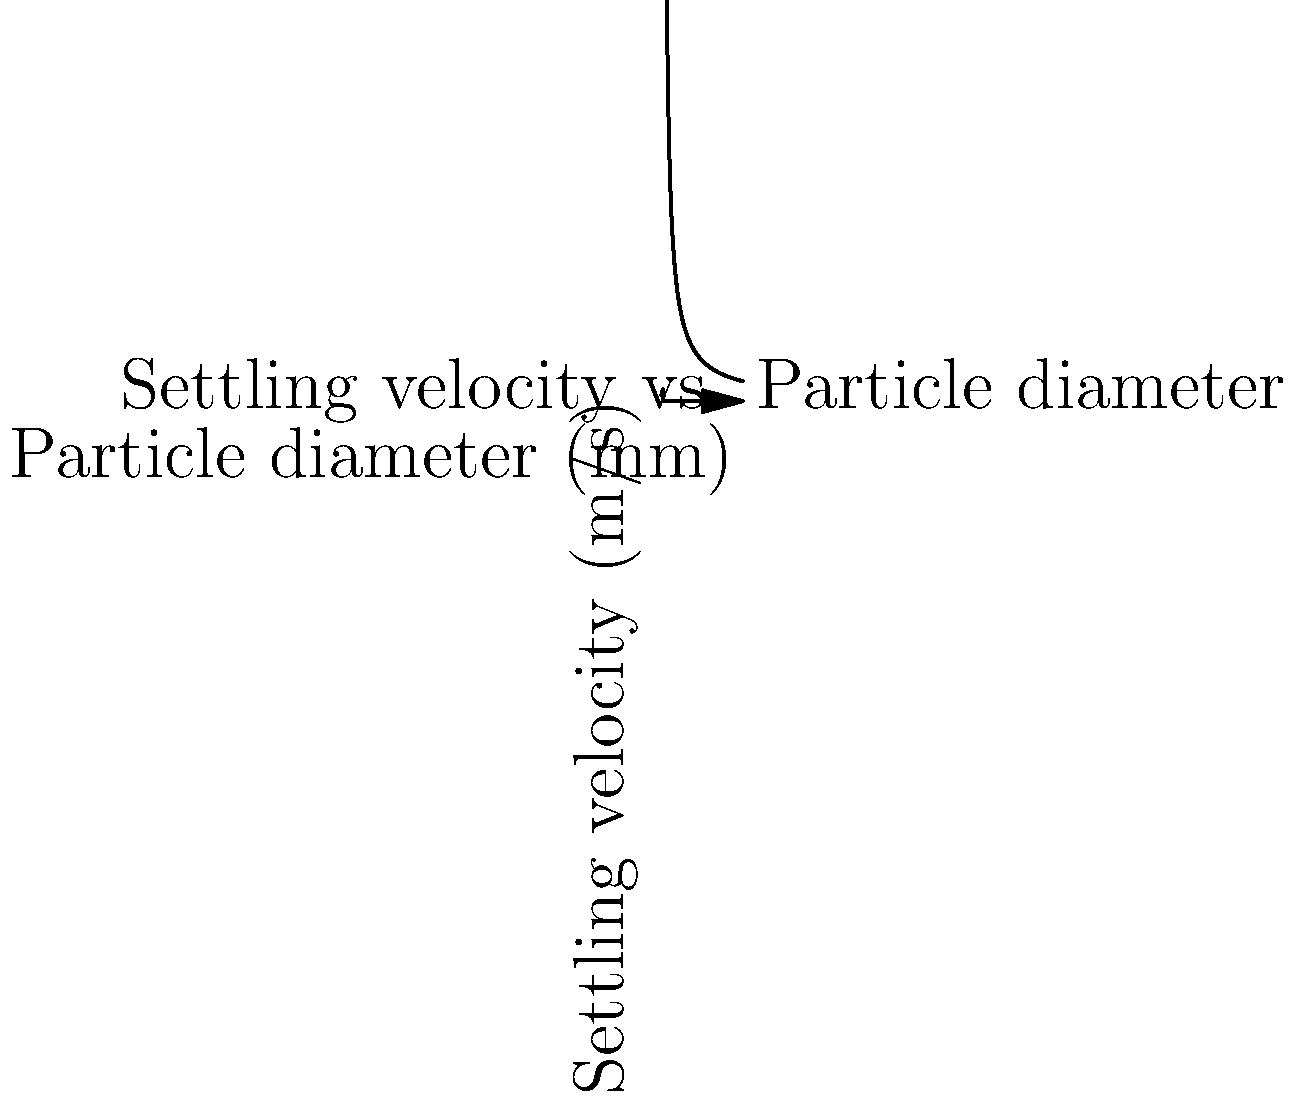A water treatment plant uses a sedimentation tank to remove suspended particles. Given the following information:
- Particle diameter: $0.5$ mm
- Particle density: $2650$ kg/m³
- Water density: $1000$ kg/m³
- Water dynamic viscosity: $0.001$ Pa·s
- Gravitational acceleration: $9.81$ m/s²
- Tank depth: $3$ m

Calculate the settling time (in seconds) for the particles to reach the bottom of the tank. Assume the particles follow Stokes' Law for settling velocity. Round your answer to the nearest integer. To solve this problem, we'll follow these steps:

1) First, we need to calculate the settling velocity using Stokes' Law:

   $$v_s = \frac{g(ρ_p - ρ_f)d^2}{18μ}$$

   Where:
   $v_s$ = settling velocity (m/s)
   $g$ = gravitational acceleration (9.81 m/s²)
   $ρ_p$ = particle density (2650 kg/m³)
   $ρ_f$ = fluid (water) density (1000 kg/m³)
   $d$ = particle diameter (0.5 mm = 0.0005 m)
   $μ$ = fluid dynamic viscosity (0.001 Pa·s)

2) Let's substitute these values:

   $$v_s = \frac{9.81(2650 - 1000)(0.0005)^2}{18(0.001)}$$

3) Calculating:

   $$v_s = \frac{9.81 * 1650 * 0.00000025}{0.018} = 0.2247 \text{ m/s}$$

4) Now that we have the settling velocity, we can calculate the settling time:

   $$t = \frac{h}{v_s}$$

   Where:
   $t$ = settling time (s)
   $h$ = tank depth (3 m)
   $v_s$ = settling velocity (0.2247 m/s)

5) Substituting:

   $$t = \frac{3}{0.2247} = 13.35 \text{ s}$$

6) Rounding to the nearest integer:

   $$t ≈ 13 \text{ s}$$
Answer: 13 s 